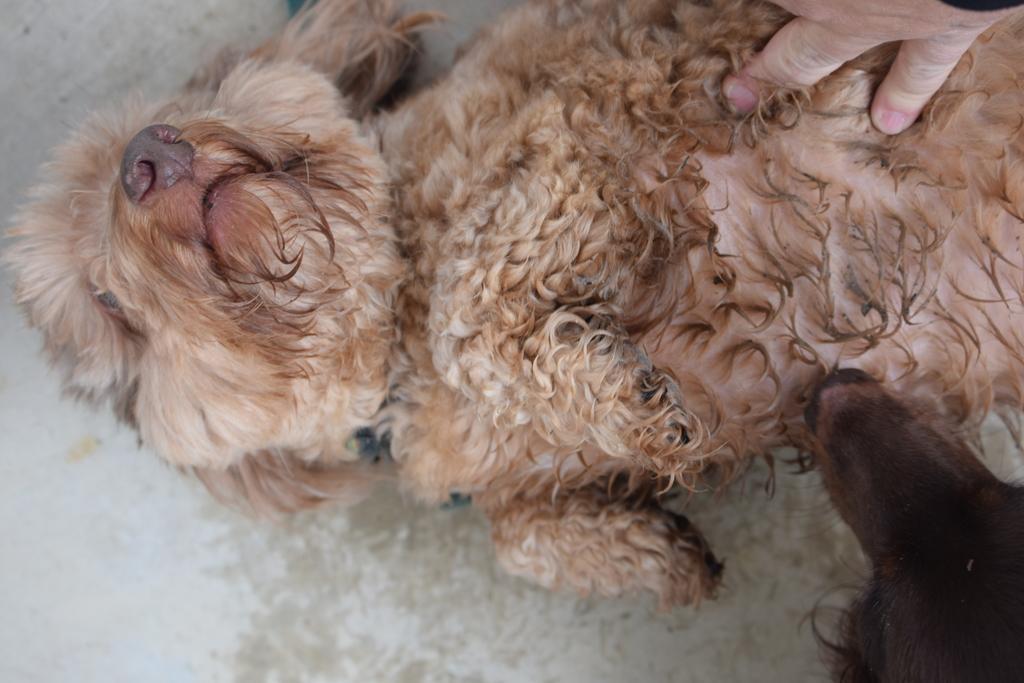Could you give a brief overview of what you see in this image? In this image there are two dogs and a person's hand. 